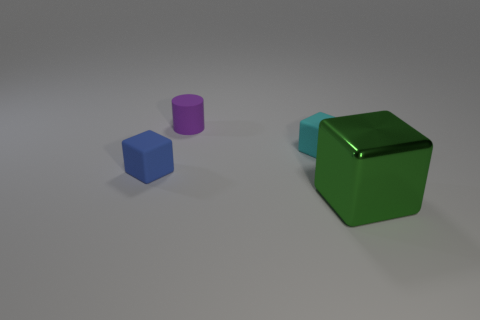Is there any other thing that is made of the same material as the green thing?
Your answer should be very brief. No. There is a cylinder that is made of the same material as the tiny blue object; what is its color?
Your response must be concise. Purple. Is the tiny blue object that is on the left side of the cyan matte cube made of the same material as the thing on the right side of the cyan rubber block?
Offer a terse response. No. There is a thing that is behind the cyan matte cube; what is its material?
Your answer should be very brief. Rubber. Is the shape of the tiny rubber object to the right of the cylinder the same as the matte object that is to the left of the rubber cylinder?
Your answer should be compact. Yes. Are any tiny purple cylinders visible?
Offer a terse response. Yes. What material is the cyan object that is the same shape as the tiny blue object?
Ensure brevity in your answer.  Rubber. There is a big shiny object; are there any things to the left of it?
Your answer should be very brief. Yes. Is the material of the tiny thing that is right of the small cylinder the same as the green cube?
Offer a terse response. No. What is the shape of the cyan rubber thing?
Offer a very short reply. Cube. 